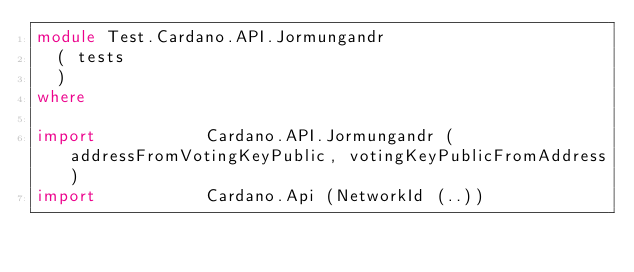<code> <loc_0><loc_0><loc_500><loc_500><_Haskell_>module Test.Cardano.API.Jormungandr
  ( tests
  )
where

import           Cardano.API.Jormungandr (addressFromVotingKeyPublic, votingKeyPublicFromAddress)
import           Cardano.Api (NetworkId (..))</code> 